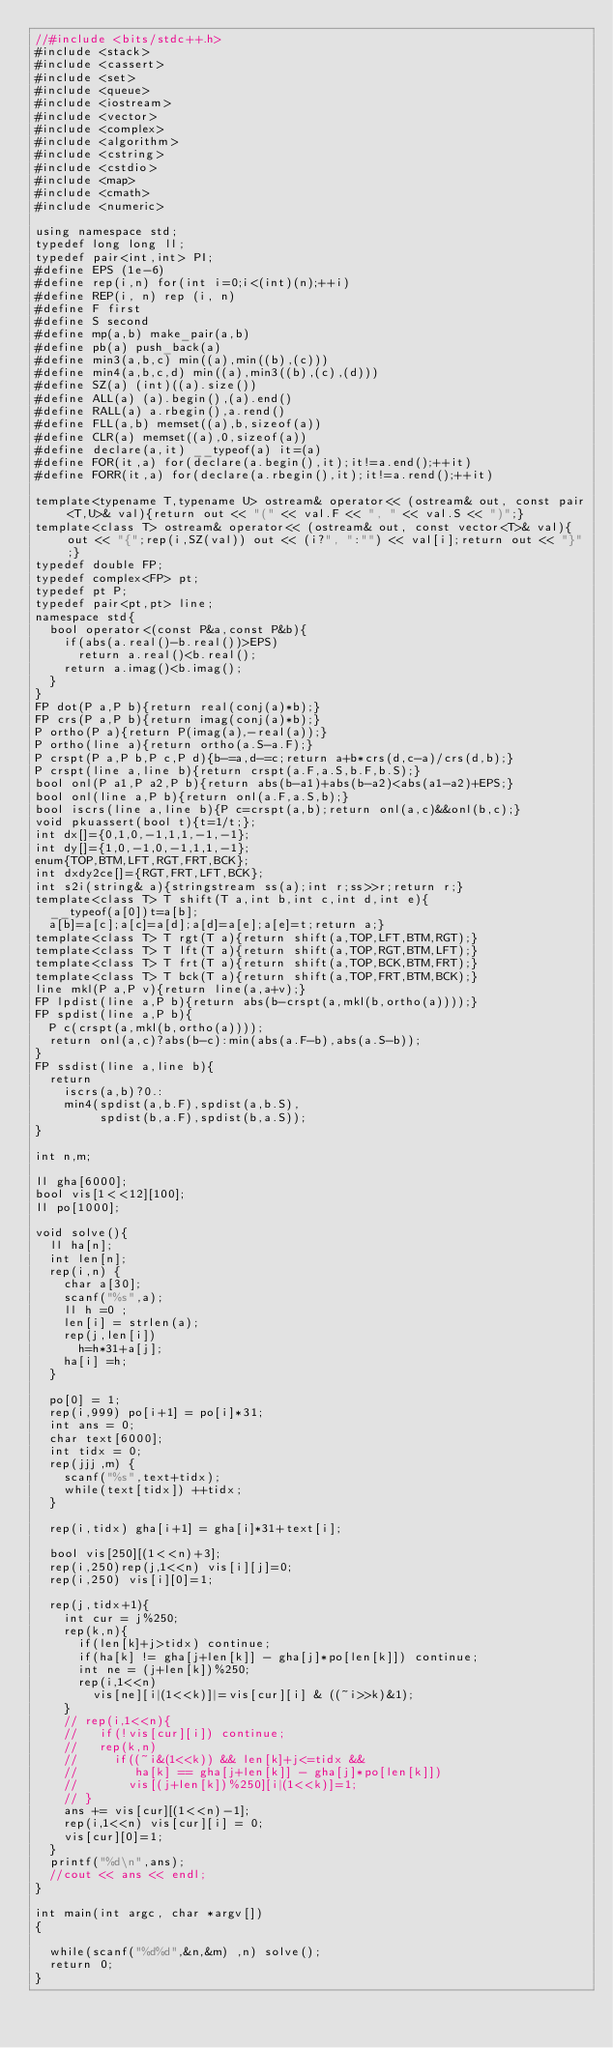<code> <loc_0><loc_0><loc_500><loc_500><_C++_>//#include <bits/stdc++.h>
#include <stack>
#include <cassert>
#include <set>
#include <queue>
#include <iostream>
#include <vector>
#include <complex>
#include <algorithm>
#include <cstring>
#include <cstdio>
#include <map>
#include <cmath>
#include <numeric>

using namespace std;
typedef long long ll;
typedef pair<int,int> PI;
#define EPS (1e-6)
#define rep(i,n) for(int i=0;i<(int)(n);++i)
#define REP(i, n) rep (i, n)
#define F first
#define S second
#define mp(a,b) make_pair(a,b)
#define pb(a) push_back(a)
#define min3(a,b,c) min((a),min((b),(c)))
#define min4(a,b,c,d) min((a),min3((b),(c),(d)))
#define SZ(a) (int)((a).size())
#define ALL(a) (a).begin(),(a).end()
#define RALL(a) a.rbegin(),a.rend()
#define FLL(a,b) memset((a),b,sizeof(a))
#define CLR(a) memset((a),0,sizeof(a))
#define declare(a,it) __typeof(a) it=(a)
#define FOR(it,a) for(declare(a.begin(),it);it!=a.end();++it)
#define FORR(it,a) for(declare(a.rbegin(),it);it!=a.rend();++it)

template<typename T,typename U> ostream& operator<< (ostream& out, const pair<T,U>& val){return out << "(" << val.F << ", " << val.S << ")";}
template<class T> ostream& operator<< (ostream& out, const vector<T>& val){out << "{";rep(i,SZ(val)) out << (i?", ":"") << val[i];return out << "}";}
typedef double FP;
typedef complex<FP> pt;
typedef pt P;
typedef pair<pt,pt> line;
namespace std{
  bool operator<(const P&a,const P&b){
    if(abs(a.real()-b.real())>EPS)
      return a.real()<b.real();
    return a.imag()<b.imag();
  }
}
FP dot(P a,P b){return real(conj(a)*b);}
FP crs(P a,P b){return imag(conj(a)*b);}
P ortho(P a){return P(imag(a),-real(a));}
P ortho(line a){return ortho(a.S-a.F);}
P crspt(P a,P b,P c,P d){b-=a,d-=c;return a+b*crs(d,c-a)/crs(d,b);}
P crspt(line a,line b){return crspt(a.F,a.S,b.F,b.S);}
bool onl(P a1,P a2,P b){return abs(b-a1)+abs(b-a2)<abs(a1-a2)+EPS;}
bool onl(line a,P b){return onl(a.F,a.S,b);}
bool iscrs(line a,line b){P c=crspt(a,b);return onl(a,c)&&onl(b,c);}
void pkuassert(bool t){t=1/t;};
int dx[]={0,1,0,-1,1,1,-1,-1};
int dy[]={1,0,-1,0,-1,1,1,-1};
enum{TOP,BTM,LFT,RGT,FRT,BCK};
int dxdy2ce[]={RGT,FRT,LFT,BCK};
int s2i(string& a){stringstream ss(a);int r;ss>>r;return r;}
template<class T> T shift(T a,int b,int c,int d,int e){
  __typeof(a[0])t=a[b];
  a[b]=a[c];a[c]=a[d];a[d]=a[e];a[e]=t;return a;}
template<class T> T rgt(T a){return shift(a,TOP,LFT,BTM,RGT);}
template<class T> T lft(T a){return shift(a,TOP,RGT,BTM,LFT);}
template<class T> T frt(T a){return shift(a,TOP,BCK,BTM,FRT);}
template<class T> T bck(T a){return shift(a,TOP,FRT,BTM,BCK);}
line mkl(P a,P v){return line(a,a+v);}
FP lpdist(line a,P b){return abs(b-crspt(a,mkl(b,ortho(a))));}
FP spdist(line a,P b){
  P c(crspt(a,mkl(b,ortho(a))));
  return onl(a,c)?abs(b-c):min(abs(a.F-b),abs(a.S-b));
}
FP ssdist(line a,line b){
  return
    iscrs(a,b)?0.:
    min4(spdist(a,b.F),spdist(a,b.S),
         spdist(b,a.F),spdist(b,a.S));
}

int n,m;

ll gha[6000];
bool vis[1<<12][100];
ll po[1000];

void solve(){
  ll ha[n];
  int len[n];
  rep(i,n) {
    char a[30];
    scanf("%s",a);
    ll h =0 ;
    len[i] = strlen(a);
    rep(j,len[i])
      h=h*31+a[j];
    ha[i] =h;
  }
  
  po[0] = 1;
  rep(i,999) po[i+1] = po[i]*31;
  int ans = 0;
  char text[6000];
  int tidx = 0;
  rep(jjj,m) {
    scanf("%s",text+tidx);
    while(text[tidx]) ++tidx;
  }
  
  rep(i,tidx) gha[i+1] = gha[i]*31+text[i];
  
  bool vis[250][(1<<n)+3];
  rep(i,250)rep(j,1<<n) vis[i][j]=0;
  rep(i,250) vis[i][0]=1;
  
  rep(j,tidx+1){
    int cur = j%250;
    rep(k,n){
      if(len[k]+j>tidx) continue;
      if(ha[k] != gha[j+len[k]] - gha[j]*po[len[k]]) continue;
      int ne = (j+len[k])%250;
      rep(i,1<<n)
        vis[ne][i|(1<<k)]|=vis[cur][i] & ((~i>>k)&1);
    }
    // rep(i,1<<n){
    //   if(!vis[cur][i]) continue;
    //   rep(k,n)
    //     if((~i&(1<<k)) && len[k]+j<=tidx &&
    //        ha[k] == gha[j+len[k]] - gha[j]*po[len[k]])
    //       vis[(j+len[k])%250][i|(1<<k)]=1;
    // }
    ans += vis[cur][(1<<n)-1];
    rep(i,1<<n) vis[cur][i] = 0;
    vis[cur][0]=1;
  }
  printf("%d\n",ans);
  //cout << ans << endl;
}

int main(int argc, char *argv[])
{
  
  while(scanf("%d%d",&n,&m) ,n) solve();
  return 0;
}</code> 